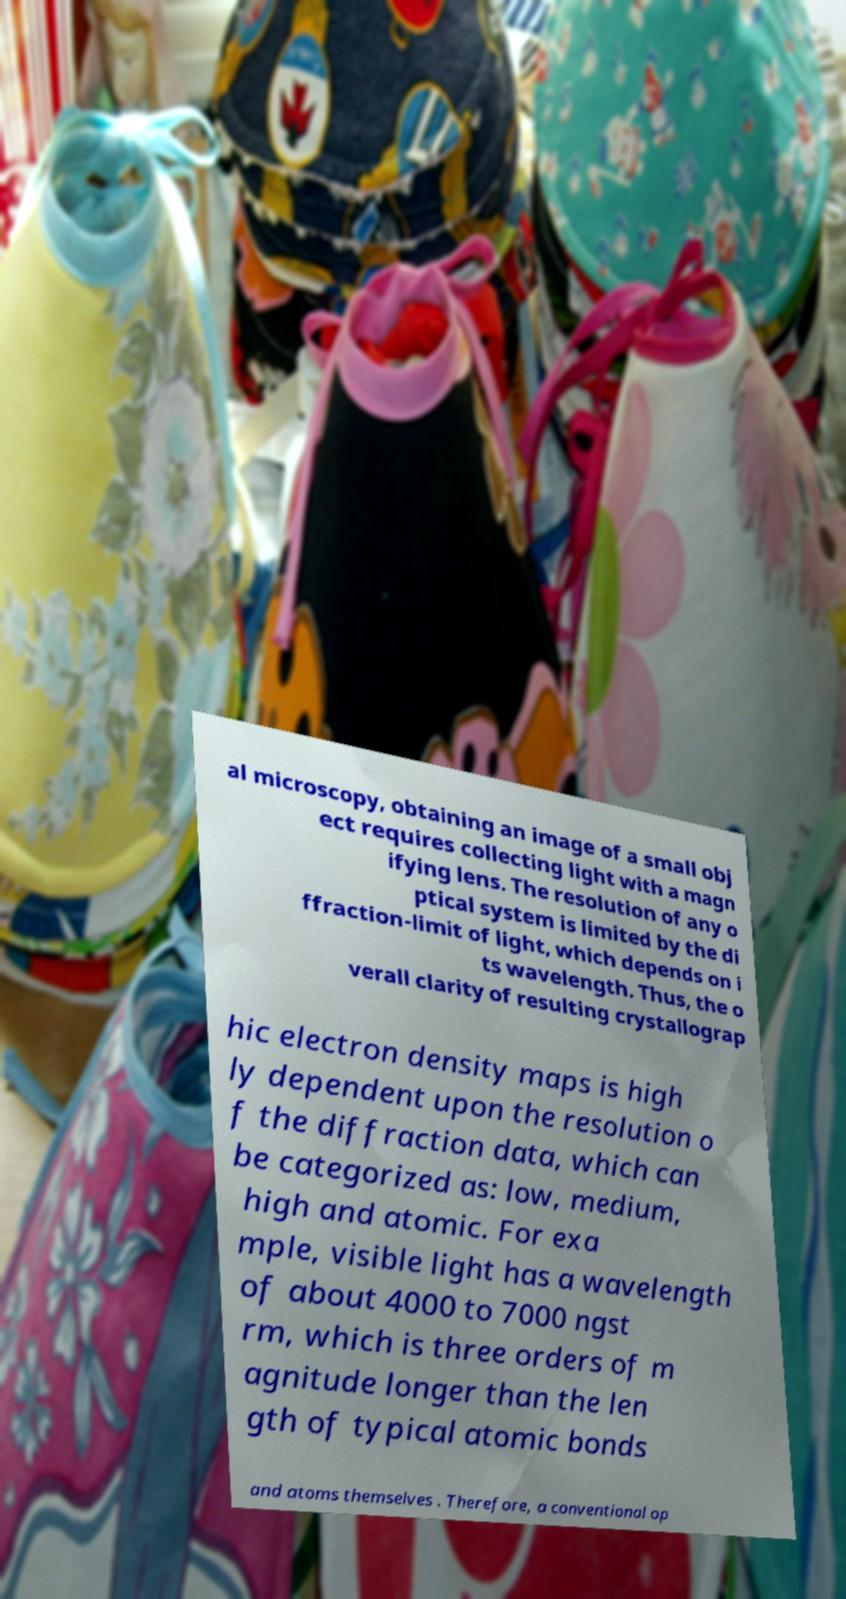For documentation purposes, I need the text within this image transcribed. Could you provide that? al microscopy, obtaining an image of a small obj ect requires collecting light with a magn ifying lens. The resolution of any o ptical system is limited by the di ffraction-limit of light, which depends on i ts wavelength. Thus, the o verall clarity of resulting crystallograp hic electron density maps is high ly dependent upon the resolution o f the diffraction data, which can be categorized as: low, medium, high and atomic. For exa mple, visible light has a wavelength of about 4000 to 7000 ngst rm, which is three orders of m agnitude longer than the len gth of typical atomic bonds and atoms themselves . Therefore, a conventional op 